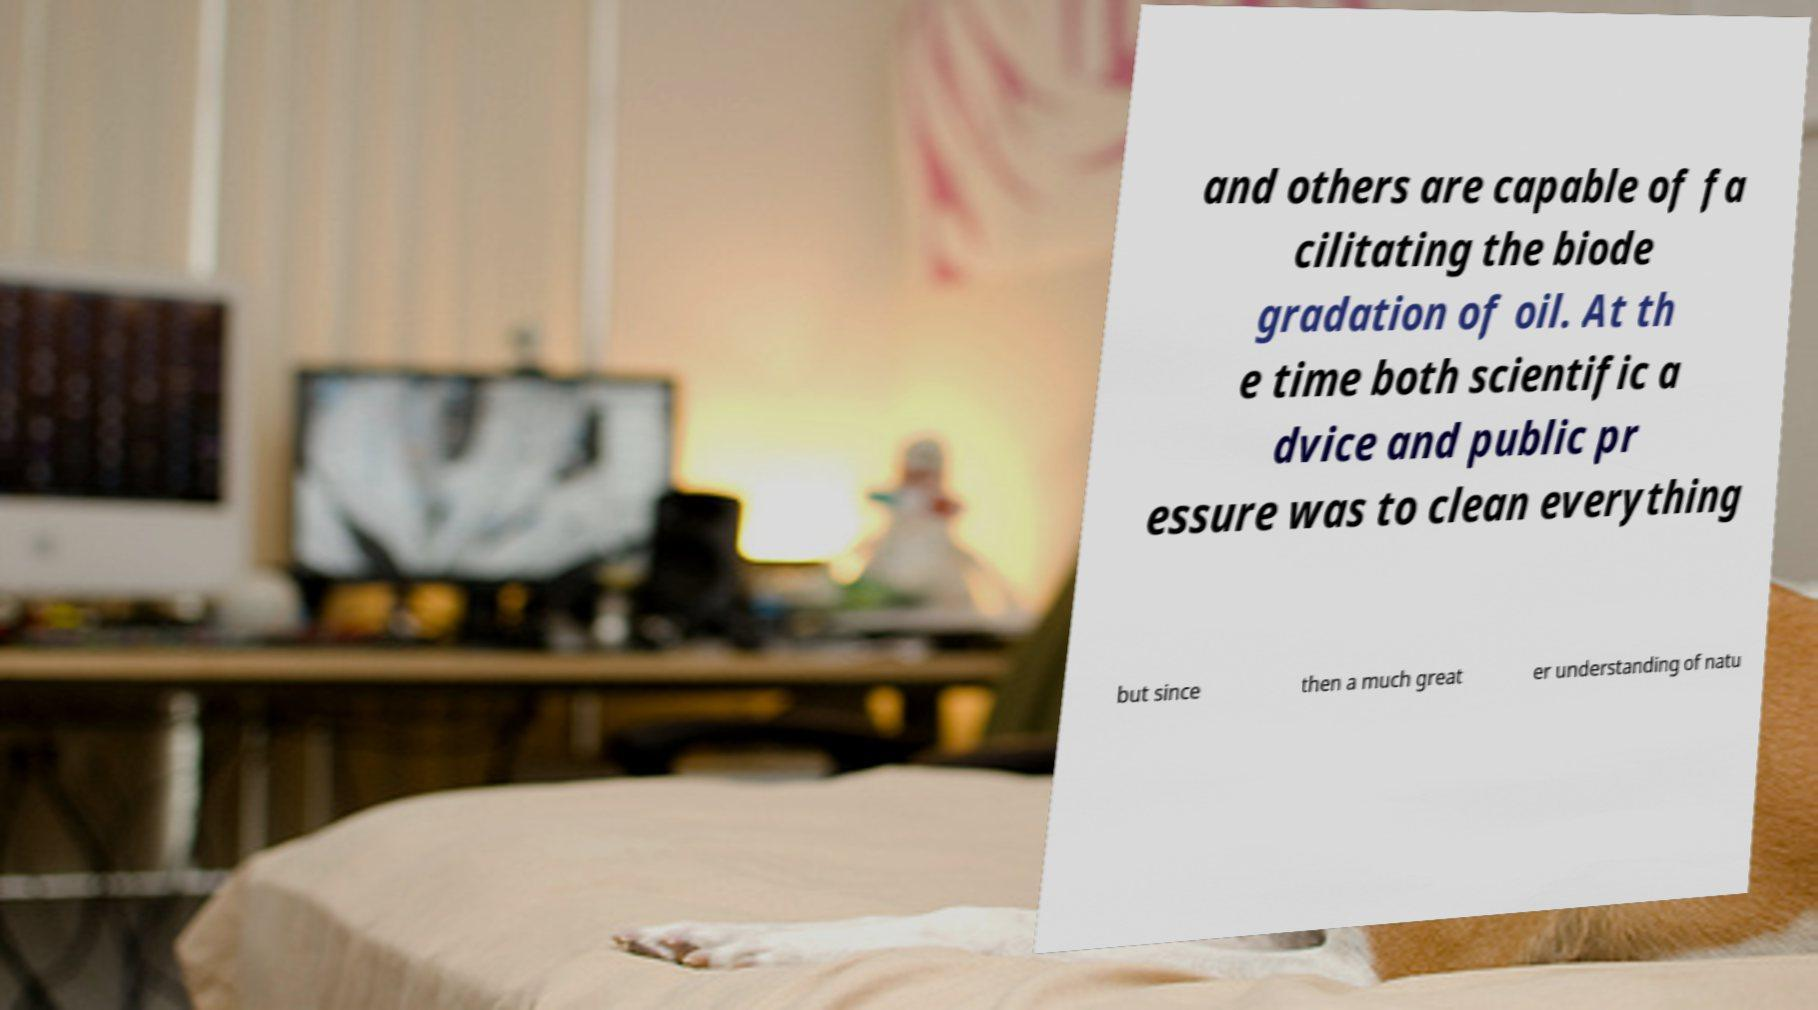Could you extract and type out the text from this image? and others are capable of fa cilitating the biode gradation of oil. At th e time both scientific a dvice and public pr essure was to clean everything but since then a much great er understanding of natu 